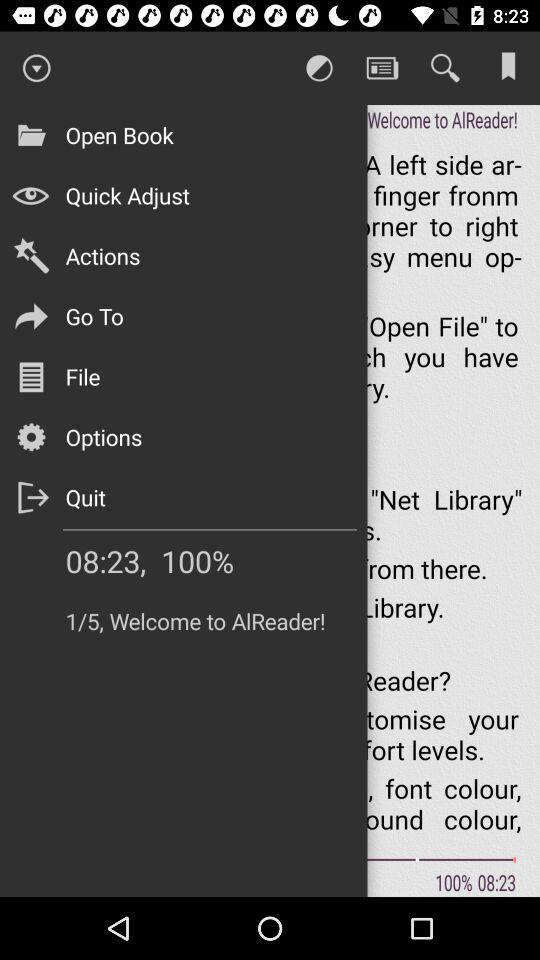What's the time shown on the screen? The time shown on the screen is 08:23. 